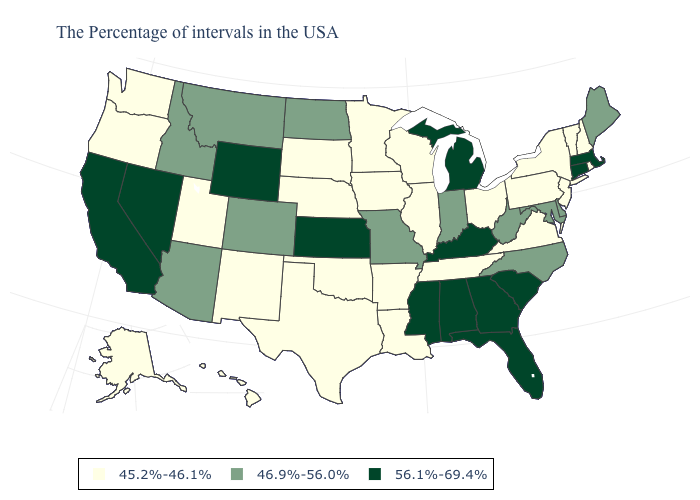What is the value of Maryland?
Short answer required. 46.9%-56.0%. Does the first symbol in the legend represent the smallest category?
Keep it brief. Yes. Does the first symbol in the legend represent the smallest category?
Be succinct. Yes. Name the states that have a value in the range 56.1%-69.4%?
Answer briefly. Massachusetts, Connecticut, South Carolina, Florida, Georgia, Michigan, Kentucky, Alabama, Mississippi, Kansas, Wyoming, Nevada, California. Name the states that have a value in the range 45.2%-46.1%?
Keep it brief. Rhode Island, New Hampshire, Vermont, New York, New Jersey, Pennsylvania, Virginia, Ohio, Tennessee, Wisconsin, Illinois, Louisiana, Arkansas, Minnesota, Iowa, Nebraska, Oklahoma, Texas, South Dakota, New Mexico, Utah, Washington, Oregon, Alaska, Hawaii. Does Florida have the highest value in the USA?
Be succinct. Yes. What is the value of Oklahoma?
Concise answer only. 45.2%-46.1%. What is the value of Florida?
Write a very short answer. 56.1%-69.4%. What is the value of Massachusetts?
Give a very brief answer. 56.1%-69.4%. What is the highest value in the South ?
Keep it brief. 56.1%-69.4%. What is the value of Florida?
Keep it brief. 56.1%-69.4%. Among the states that border Virginia , does Kentucky have the highest value?
Give a very brief answer. Yes. Does Pennsylvania have the lowest value in the Northeast?
Answer briefly. Yes. What is the value of Massachusetts?
Answer briefly. 56.1%-69.4%. What is the value of Montana?
Give a very brief answer. 46.9%-56.0%. 